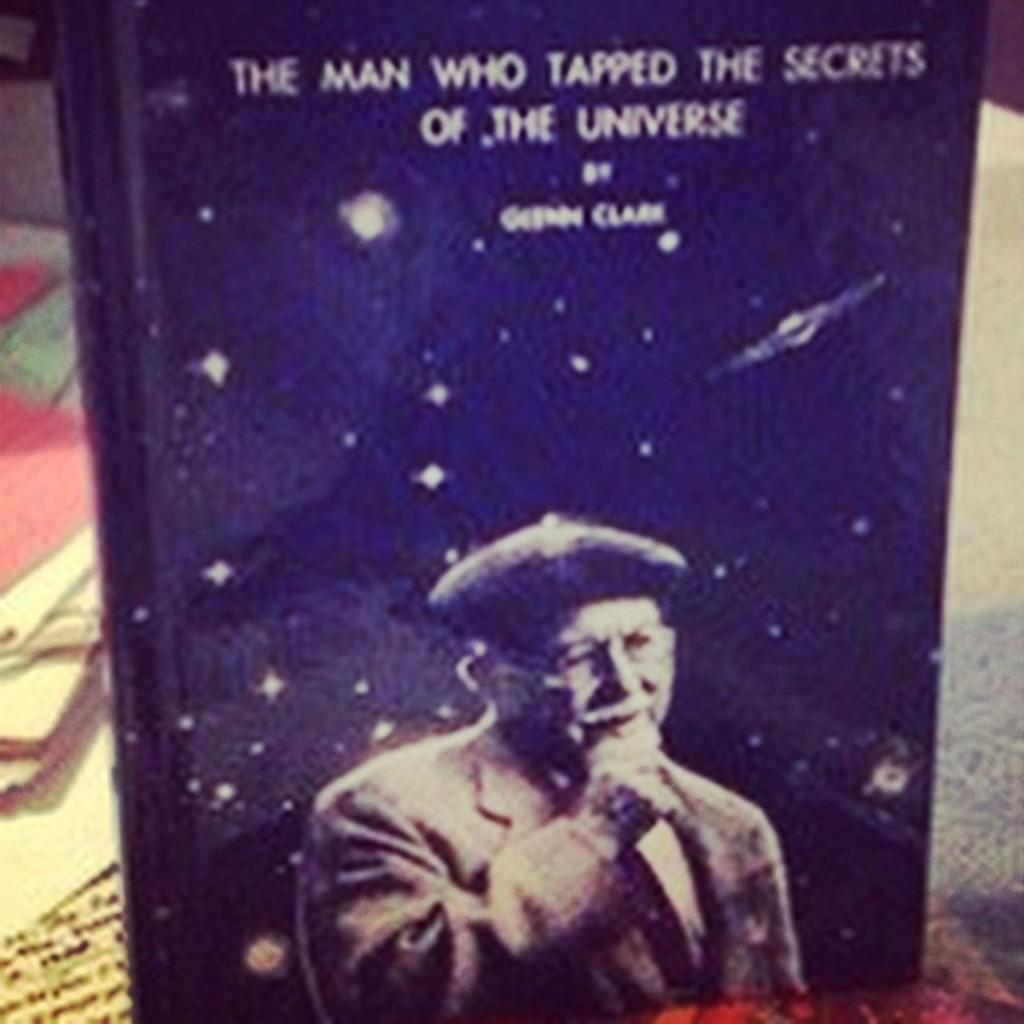Provide a one-sentence caption for the provided image. a book titled the man who tapped the secrets of the universe written by george clark. 